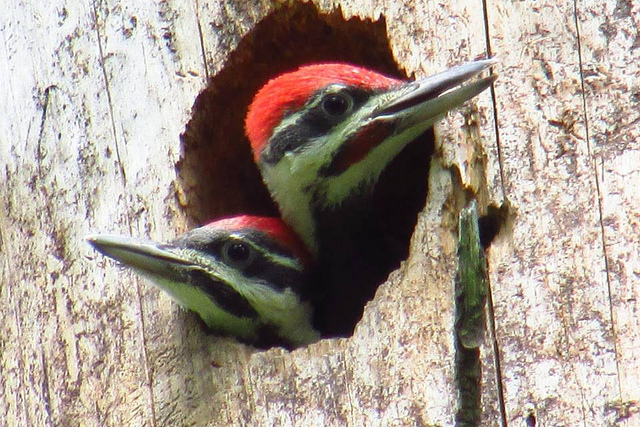What species of bird is pictured here? The birds in the image are likely pileated woodpeckers, recognizable by their striking red crest and black and white coloring. 